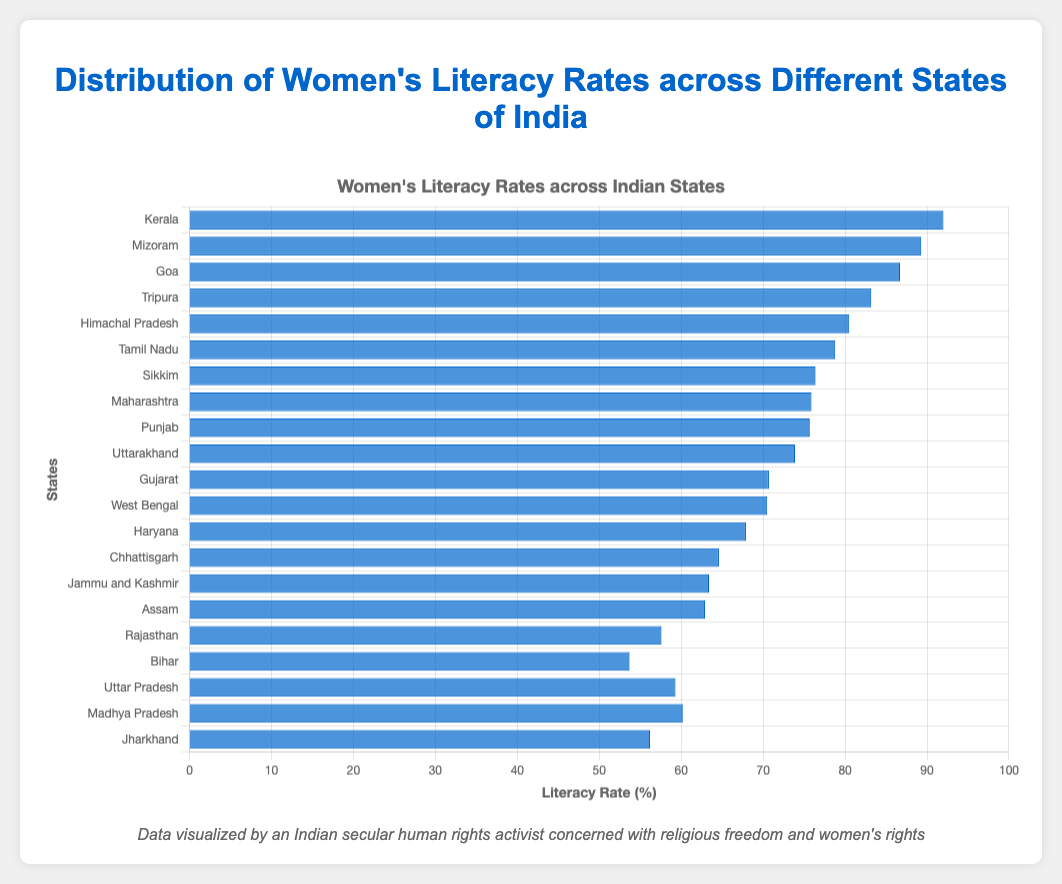What's the state with the highest women's literacy rate? Looking at the chart, the state with the tallest blue bar represents the highest literacy rate. Kerala has the tallest bar.
Answer: Kerala Which state has the lowest women's literacy rate? Observing the shortest blue bar on the chart identifies the state with the lowest literacy rate. Bihar has the shortest bar.
Answer: Bihar Compare the women's literacy rates between Tamil Nadu and Gujarat. Which state has a higher rate? By comparing the height of the bars for Tamil Nadu and Gujarat, the bar for Tamil Nadu is taller. Hence, Tamil Nadu has a higher literacy rate than Gujarat.
Answer: Tamil Nadu What is the difference in literacy rates between the highest and lowest ranked states? The highest literacy rate is Kerala at 92.0%, and the lowest is Bihar at 53.7%. The difference is calculated as 92.0 - 53.7.
Answer: 38.3% Are there more states with a literacy rate above 75% or below 75%? Count the number of bars taller than the level representing 75% and the number of bars shorter than 75%. There are 9 states above 75% and 11 states below 75%.
Answer: Below 75% Which states have a literacy rate between 60% and 70%? Identify the bars whose heights fall between the 60% and 70% mark on the chart. States in this range are Haryana, Chhattisgarh, Jammu and Kashmir, Assam, Gujarat, and West Bengal.
Answer: Haryana, Chhattisgarh, Jammu and Kashmir, Assam, Gujarat, West Bengal What is the average women's literacy rate of the top 5 states? The top 5 states are Kerala, Mizoram, Goa, Tripura, and Himachal Pradesh. Their rates are 92.0, 89.3, 86.7, 83.2, and 80.5, respectively. The sum is 92.0 + 89.3 + 86.7 + 83.2 + 80.5 = 431.7. The average is 431.7 / 5.
Answer: 86.34% How many states have a literacy rate higher than 80%? Count the number of blue bars that are taller than the 80% mark. The states are Kerala, Mizoram, Goa, Tripura, and Himachal Pradesh, giving a total of 5 states.
Answer: 5 What is the median women's literacy rate? Arrange all the literacy rates in ascending order and find the middle value. The sorted order is 53.7, 56.2, 57.6, 59.3, 60.2, 62.9, 63.4, 64.6, 67.9, 70.5, 70.7, 73.9, 75.7, 75.9, 76.4, 78.8, 80.5, 83.2, 86.7, 89.3, 92.0. The median value (11th value) is 70.7%.
Answer: 70.7% Which state(s) have a literacy rate that's closest to the national average (assume the national average is 68%)? Identify the bar closest to the 68% mark. The state with a literacy rate nearest to 68% is Haryana with 67.9%.
Answer: Haryana 